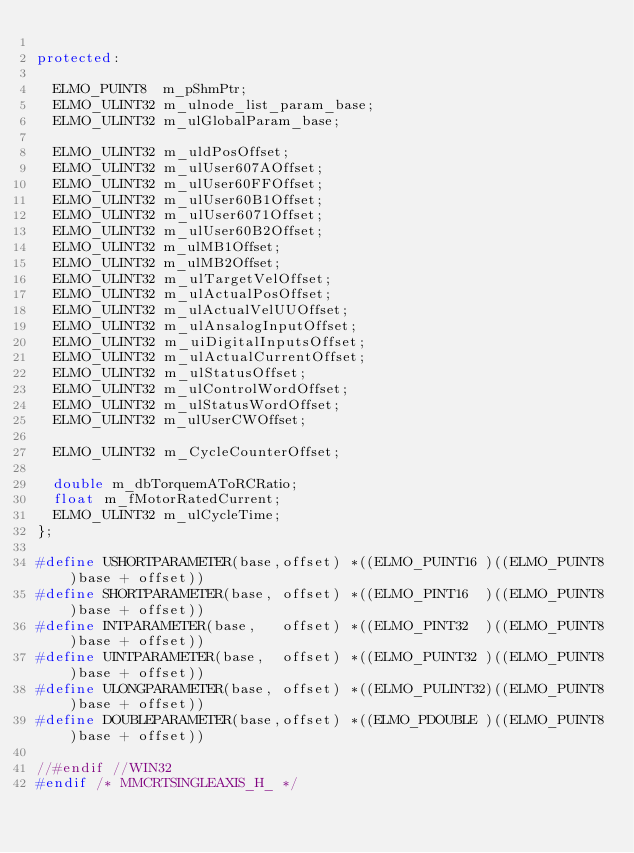<code> <loc_0><loc_0><loc_500><loc_500><_C++_>
protected:

	ELMO_PUINT8  m_pShmPtr;
	ELMO_ULINT32 m_ulnode_list_param_base;
	ELMO_ULINT32 m_ulGlobalParam_base;

	ELMO_ULINT32 m_uldPosOffset;
	ELMO_ULINT32 m_ulUser607AOffset;
	ELMO_ULINT32 m_ulUser60FFOffset;
	ELMO_ULINT32 m_ulUser60B1Offset;
	ELMO_ULINT32 m_ulUser6071Offset;
	ELMO_ULINT32 m_ulUser60B2Offset;
	ELMO_ULINT32 m_ulMB1Offset;
	ELMO_ULINT32 m_ulMB2Offset;
	ELMO_ULINT32 m_ulTargetVelOffset;
	ELMO_ULINT32 m_ulActualPosOffset;
	ELMO_ULINT32 m_ulActualVelUUOffset;
	ELMO_ULINT32 m_ulAnsalogInputOffset;
	ELMO_ULINT32 m_uiDigitalInputsOffset;
	ELMO_ULINT32 m_ulActualCurrentOffset;
	ELMO_ULINT32 m_ulStatusOffset;
	ELMO_ULINT32 m_ulControlWordOffset;
	ELMO_ULINT32 m_ulStatusWordOffset;
	ELMO_ULINT32 m_ulUserCWOffset;

	ELMO_ULINT32 m_CycleCounterOffset;

	double m_dbTorquemAToRCRatio;
	float m_fMotorRatedCurrent;
	ELMO_ULINT32 m_ulCycleTime;
};

#define USHORTPARAMETER(base,offset) *((ELMO_PUINT16 )((ELMO_PUINT8)base + offset))
#define SHORTPARAMETER(base, offset) *((ELMO_PINT16  )((ELMO_PUINT8)base + offset))
#define INTPARAMETER(base,   offset) *((ELMO_PINT32  )((ELMO_PUINT8)base + offset))
#define UINTPARAMETER(base,  offset) *((ELMO_PUINT32 )((ELMO_PUINT8)base + offset))
#define ULONGPARAMETER(base, offset) *((ELMO_PULINT32)((ELMO_PUINT8)base + offset))
#define DOUBLEPARAMETER(base,offset) *((ELMO_PDOUBLE )((ELMO_PUINT8)base + offset))

//#endif //WIN32
#endif /* MMCRTSINGLEAXIS_H_ */
</code> 